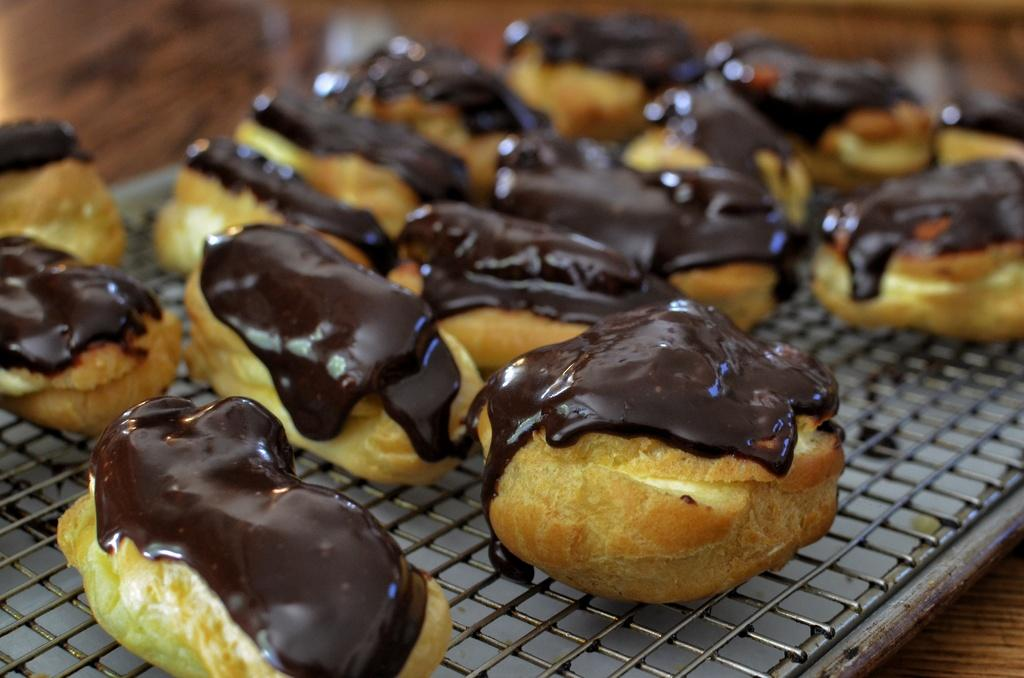What is the main subject of the image? There is a cake in the image. What is on top of the cake? There is hot chocolate sauce on the cake. What can be seen at the bottom of the image? There is an iron mesh at the bottom of the image. How would you describe the background of the image? The background of the image is blurred. What type of magic is being performed in the image? There is no magic being performed in the image; it features a cake with hot chocolate sauce and an iron mesh. Can you tell me where the hall is located in the image? There is no hall present in the image. 